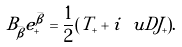Convert formula to latex. <formula><loc_0><loc_0><loc_500><loc_500>B _ { \bar { \beta } } e _ { + } ^ { \bar { \beta } } = \frac { 1 } { 2 } ( T _ { + } + i \ u D J _ { + } ) .</formula> 